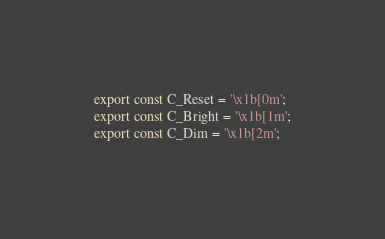Convert code to text. <code><loc_0><loc_0><loc_500><loc_500><_TypeScript_>export const C_Reset = '\x1b[0m';
export const C_Bright = '\x1b[1m';
export const C_Dim = '\x1b[2m';</code> 